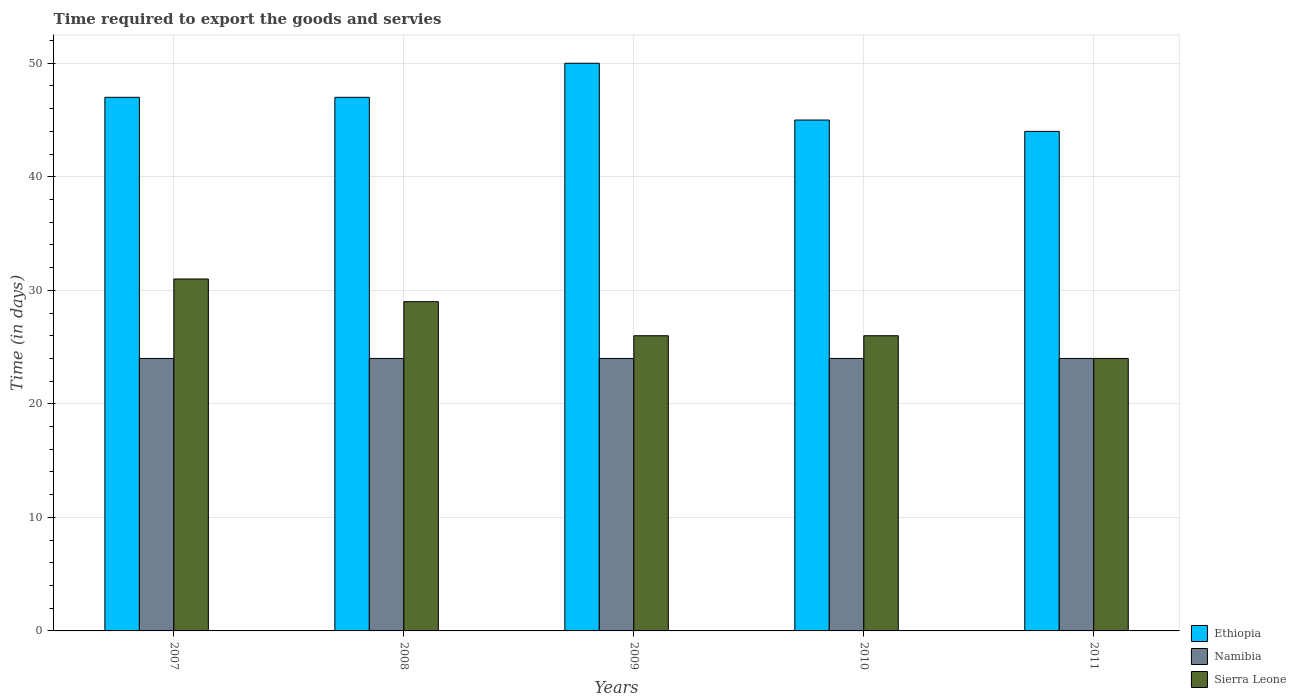How many different coloured bars are there?
Keep it short and to the point. 3. How many groups of bars are there?
Offer a very short reply. 5. Are the number of bars per tick equal to the number of legend labels?
Provide a short and direct response. Yes. How many bars are there on the 4th tick from the left?
Your answer should be compact. 3. How many bars are there on the 1st tick from the right?
Provide a short and direct response. 3. What is the label of the 3rd group of bars from the left?
Your response must be concise. 2009. In how many cases, is the number of bars for a given year not equal to the number of legend labels?
Provide a succinct answer. 0. What is the number of days required to export the goods and services in Sierra Leone in 2010?
Give a very brief answer. 26. Across all years, what is the maximum number of days required to export the goods and services in Sierra Leone?
Your answer should be compact. 31. Across all years, what is the minimum number of days required to export the goods and services in Namibia?
Ensure brevity in your answer.  24. In which year was the number of days required to export the goods and services in Ethiopia minimum?
Your answer should be very brief. 2011. What is the total number of days required to export the goods and services in Namibia in the graph?
Offer a terse response. 120. What is the difference between the number of days required to export the goods and services in Namibia in 2008 and the number of days required to export the goods and services in Sierra Leone in 2011?
Provide a succinct answer. 0. What is the average number of days required to export the goods and services in Ethiopia per year?
Give a very brief answer. 46.6. In the year 2010, what is the difference between the number of days required to export the goods and services in Namibia and number of days required to export the goods and services in Sierra Leone?
Your response must be concise. -2. In how many years, is the number of days required to export the goods and services in Ethiopia greater than 36 days?
Make the answer very short. 5. What is the ratio of the number of days required to export the goods and services in Sierra Leone in 2007 to that in 2009?
Offer a very short reply. 1.19. What is the difference between the highest and the lowest number of days required to export the goods and services in Sierra Leone?
Make the answer very short. 7. Is the sum of the number of days required to export the goods and services in Sierra Leone in 2008 and 2010 greater than the maximum number of days required to export the goods and services in Ethiopia across all years?
Ensure brevity in your answer.  Yes. What does the 2nd bar from the left in 2010 represents?
Give a very brief answer. Namibia. What does the 2nd bar from the right in 2010 represents?
Provide a short and direct response. Namibia. How many bars are there?
Your response must be concise. 15. Are all the bars in the graph horizontal?
Give a very brief answer. No. Are the values on the major ticks of Y-axis written in scientific E-notation?
Your answer should be compact. No. Does the graph contain any zero values?
Provide a short and direct response. No. Does the graph contain grids?
Your answer should be compact. Yes. Where does the legend appear in the graph?
Your answer should be compact. Bottom right. How are the legend labels stacked?
Give a very brief answer. Vertical. What is the title of the graph?
Your response must be concise. Time required to export the goods and servies. What is the label or title of the X-axis?
Offer a very short reply. Years. What is the label or title of the Y-axis?
Ensure brevity in your answer.  Time (in days). What is the Time (in days) of Sierra Leone in 2007?
Keep it short and to the point. 31. What is the Time (in days) of Namibia in 2009?
Offer a very short reply. 24. What is the Time (in days) in Sierra Leone in 2009?
Your answer should be compact. 26. What is the Time (in days) of Ethiopia in 2010?
Your answer should be very brief. 45. What is the Time (in days) of Namibia in 2010?
Offer a terse response. 24. What is the Time (in days) in Namibia in 2011?
Ensure brevity in your answer.  24. Across all years, what is the minimum Time (in days) in Ethiopia?
Your answer should be very brief. 44. Across all years, what is the minimum Time (in days) of Sierra Leone?
Provide a succinct answer. 24. What is the total Time (in days) in Ethiopia in the graph?
Provide a short and direct response. 233. What is the total Time (in days) of Namibia in the graph?
Make the answer very short. 120. What is the total Time (in days) of Sierra Leone in the graph?
Offer a very short reply. 136. What is the difference between the Time (in days) in Namibia in 2007 and that in 2008?
Your response must be concise. 0. What is the difference between the Time (in days) of Sierra Leone in 2007 and that in 2008?
Keep it short and to the point. 2. What is the difference between the Time (in days) in Namibia in 2007 and that in 2009?
Ensure brevity in your answer.  0. What is the difference between the Time (in days) in Sierra Leone in 2007 and that in 2009?
Your answer should be very brief. 5. What is the difference between the Time (in days) in Namibia in 2007 and that in 2010?
Give a very brief answer. 0. What is the difference between the Time (in days) in Sierra Leone in 2007 and that in 2010?
Your answer should be very brief. 5. What is the difference between the Time (in days) of Namibia in 2007 and that in 2011?
Your answer should be very brief. 0. What is the difference between the Time (in days) in Ethiopia in 2008 and that in 2009?
Make the answer very short. -3. What is the difference between the Time (in days) in Namibia in 2008 and that in 2009?
Your response must be concise. 0. What is the difference between the Time (in days) in Sierra Leone in 2008 and that in 2009?
Ensure brevity in your answer.  3. What is the difference between the Time (in days) in Namibia in 2008 and that in 2010?
Offer a very short reply. 0. What is the difference between the Time (in days) of Sierra Leone in 2008 and that in 2010?
Your answer should be very brief. 3. What is the difference between the Time (in days) of Sierra Leone in 2008 and that in 2011?
Give a very brief answer. 5. What is the difference between the Time (in days) in Ethiopia in 2009 and that in 2010?
Provide a short and direct response. 5. What is the difference between the Time (in days) in Namibia in 2009 and that in 2010?
Your response must be concise. 0. What is the difference between the Time (in days) of Sierra Leone in 2009 and that in 2010?
Provide a succinct answer. 0. What is the difference between the Time (in days) of Ethiopia in 2009 and that in 2011?
Ensure brevity in your answer.  6. What is the difference between the Time (in days) of Sierra Leone in 2009 and that in 2011?
Your response must be concise. 2. What is the difference between the Time (in days) of Ethiopia in 2007 and the Time (in days) of Namibia in 2008?
Your response must be concise. 23. What is the difference between the Time (in days) of Ethiopia in 2007 and the Time (in days) of Sierra Leone in 2009?
Offer a terse response. 21. What is the difference between the Time (in days) of Namibia in 2007 and the Time (in days) of Sierra Leone in 2009?
Provide a succinct answer. -2. What is the difference between the Time (in days) of Ethiopia in 2007 and the Time (in days) of Namibia in 2010?
Ensure brevity in your answer.  23. What is the difference between the Time (in days) in Ethiopia in 2007 and the Time (in days) in Sierra Leone in 2010?
Make the answer very short. 21. What is the difference between the Time (in days) in Namibia in 2007 and the Time (in days) in Sierra Leone in 2010?
Your response must be concise. -2. What is the difference between the Time (in days) of Namibia in 2007 and the Time (in days) of Sierra Leone in 2011?
Ensure brevity in your answer.  0. What is the difference between the Time (in days) of Ethiopia in 2008 and the Time (in days) of Namibia in 2009?
Provide a short and direct response. 23. What is the difference between the Time (in days) of Ethiopia in 2008 and the Time (in days) of Sierra Leone in 2009?
Offer a very short reply. 21. What is the difference between the Time (in days) in Namibia in 2008 and the Time (in days) in Sierra Leone in 2009?
Offer a very short reply. -2. What is the difference between the Time (in days) of Ethiopia in 2008 and the Time (in days) of Namibia in 2010?
Your answer should be compact. 23. What is the difference between the Time (in days) of Ethiopia in 2008 and the Time (in days) of Namibia in 2011?
Provide a succinct answer. 23. What is the difference between the Time (in days) in Ethiopia in 2008 and the Time (in days) in Sierra Leone in 2011?
Your answer should be very brief. 23. What is the difference between the Time (in days) in Ethiopia in 2009 and the Time (in days) in Namibia in 2010?
Offer a terse response. 26. What is the difference between the Time (in days) of Ethiopia in 2009 and the Time (in days) of Sierra Leone in 2010?
Offer a very short reply. 24. What is the difference between the Time (in days) of Namibia in 2009 and the Time (in days) of Sierra Leone in 2010?
Your response must be concise. -2. What is the difference between the Time (in days) of Ethiopia in 2009 and the Time (in days) of Sierra Leone in 2011?
Your answer should be very brief. 26. What is the difference between the Time (in days) in Namibia in 2009 and the Time (in days) in Sierra Leone in 2011?
Offer a very short reply. 0. What is the difference between the Time (in days) of Ethiopia in 2010 and the Time (in days) of Namibia in 2011?
Provide a succinct answer. 21. What is the difference between the Time (in days) in Ethiopia in 2010 and the Time (in days) in Sierra Leone in 2011?
Offer a terse response. 21. What is the average Time (in days) of Ethiopia per year?
Make the answer very short. 46.6. What is the average Time (in days) of Namibia per year?
Provide a succinct answer. 24. What is the average Time (in days) in Sierra Leone per year?
Your answer should be very brief. 27.2. In the year 2007, what is the difference between the Time (in days) in Namibia and Time (in days) in Sierra Leone?
Offer a terse response. -7. In the year 2008, what is the difference between the Time (in days) of Ethiopia and Time (in days) of Namibia?
Your response must be concise. 23. In the year 2008, what is the difference between the Time (in days) of Ethiopia and Time (in days) of Sierra Leone?
Make the answer very short. 18. In the year 2010, what is the difference between the Time (in days) in Ethiopia and Time (in days) in Sierra Leone?
Give a very brief answer. 19. In the year 2010, what is the difference between the Time (in days) in Namibia and Time (in days) in Sierra Leone?
Your answer should be compact. -2. In the year 2011, what is the difference between the Time (in days) in Namibia and Time (in days) in Sierra Leone?
Keep it short and to the point. 0. What is the ratio of the Time (in days) in Ethiopia in 2007 to that in 2008?
Offer a very short reply. 1. What is the ratio of the Time (in days) of Sierra Leone in 2007 to that in 2008?
Keep it short and to the point. 1.07. What is the ratio of the Time (in days) in Ethiopia in 2007 to that in 2009?
Make the answer very short. 0.94. What is the ratio of the Time (in days) in Namibia in 2007 to that in 2009?
Offer a very short reply. 1. What is the ratio of the Time (in days) of Sierra Leone in 2007 to that in 2009?
Provide a short and direct response. 1.19. What is the ratio of the Time (in days) in Ethiopia in 2007 to that in 2010?
Make the answer very short. 1.04. What is the ratio of the Time (in days) of Namibia in 2007 to that in 2010?
Your answer should be compact. 1. What is the ratio of the Time (in days) in Sierra Leone in 2007 to that in 2010?
Offer a very short reply. 1.19. What is the ratio of the Time (in days) in Ethiopia in 2007 to that in 2011?
Your answer should be compact. 1.07. What is the ratio of the Time (in days) in Namibia in 2007 to that in 2011?
Make the answer very short. 1. What is the ratio of the Time (in days) in Sierra Leone in 2007 to that in 2011?
Make the answer very short. 1.29. What is the ratio of the Time (in days) in Ethiopia in 2008 to that in 2009?
Ensure brevity in your answer.  0.94. What is the ratio of the Time (in days) of Namibia in 2008 to that in 2009?
Offer a terse response. 1. What is the ratio of the Time (in days) of Sierra Leone in 2008 to that in 2009?
Make the answer very short. 1.12. What is the ratio of the Time (in days) in Ethiopia in 2008 to that in 2010?
Provide a succinct answer. 1.04. What is the ratio of the Time (in days) in Sierra Leone in 2008 to that in 2010?
Your answer should be compact. 1.12. What is the ratio of the Time (in days) of Ethiopia in 2008 to that in 2011?
Your answer should be very brief. 1.07. What is the ratio of the Time (in days) of Namibia in 2008 to that in 2011?
Your response must be concise. 1. What is the ratio of the Time (in days) of Sierra Leone in 2008 to that in 2011?
Your response must be concise. 1.21. What is the ratio of the Time (in days) of Ethiopia in 2009 to that in 2010?
Your answer should be very brief. 1.11. What is the ratio of the Time (in days) in Namibia in 2009 to that in 2010?
Your answer should be compact. 1. What is the ratio of the Time (in days) of Sierra Leone in 2009 to that in 2010?
Provide a succinct answer. 1. What is the ratio of the Time (in days) in Ethiopia in 2009 to that in 2011?
Offer a terse response. 1.14. What is the ratio of the Time (in days) in Sierra Leone in 2009 to that in 2011?
Your answer should be very brief. 1.08. What is the ratio of the Time (in days) of Ethiopia in 2010 to that in 2011?
Your answer should be compact. 1.02. What is the ratio of the Time (in days) of Namibia in 2010 to that in 2011?
Your response must be concise. 1. What is the difference between the highest and the second highest Time (in days) of Ethiopia?
Your response must be concise. 3. What is the difference between the highest and the second highest Time (in days) in Namibia?
Provide a short and direct response. 0. What is the difference between the highest and the lowest Time (in days) in Ethiopia?
Your answer should be compact. 6. What is the difference between the highest and the lowest Time (in days) in Sierra Leone?
Offer a very short reply. 7. 